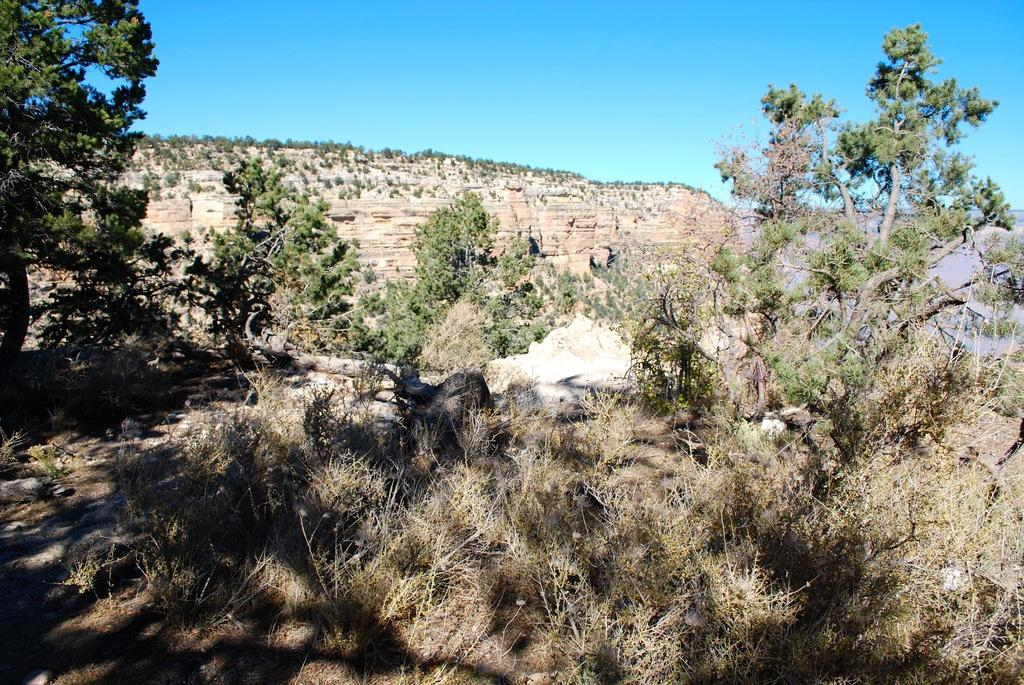What type of vegetation is present at the bottom of the picture? There are trees and plants at the bottom of the picture. What can be seen in the background of the picture? There are trees and hills in the background of the picture. What is visible at the top of the picture? The sky is visible at the top of the picture. What color is the sky in the image? The color of the sky is blue. What is the way to the canvas in the image? There is no mention of a canvas or a way in the image. The image features trees, plants, hills, and a blue sky. 